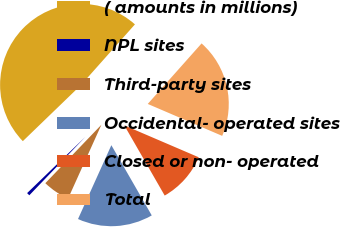Convert chart. <chart><loc_0><loc_0><loc_500><loc_500><pie_chart><fcel>( amounts in millions)<fcel>NPL sites<fcel>Third-party sites<fcel>Occidental- operated sites<fcel>Closed or non- operated<fcel>Total<nl><fcel>48.79%<fcel>0.61%<fcel>5.42%<fcel>15.06%<fcel>10.24%<fcel>19.88%<nl></chart> 